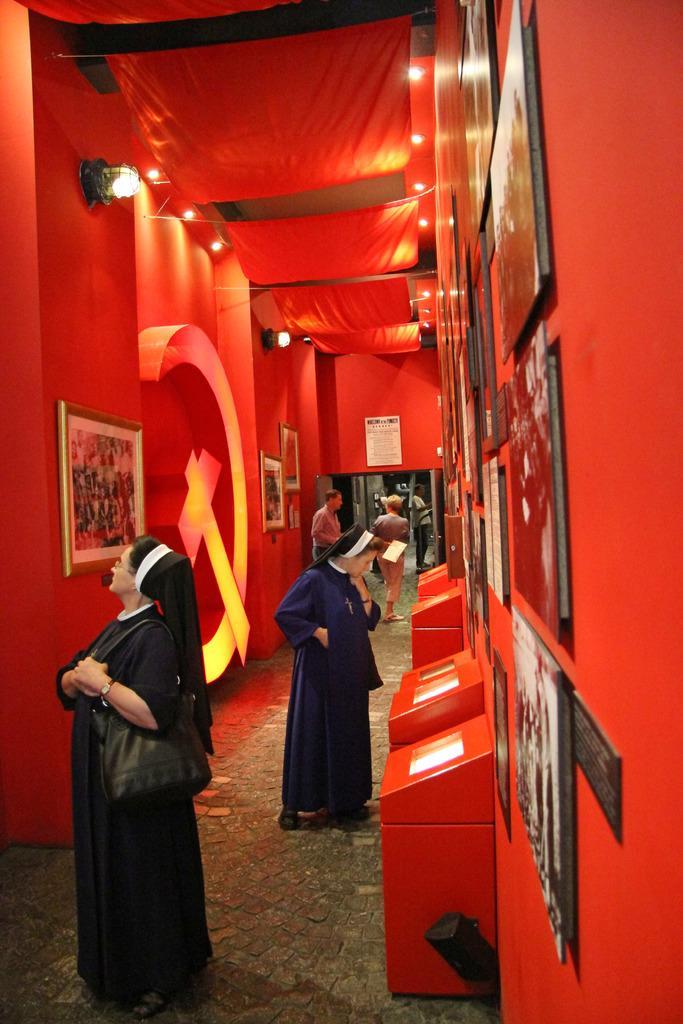Describe this image in one or two sentences. In this image, we can see a few people, wall, photo frames, poster, lights and clothes. At the bottom, we can see a few red boxes are placed on the walkway. 